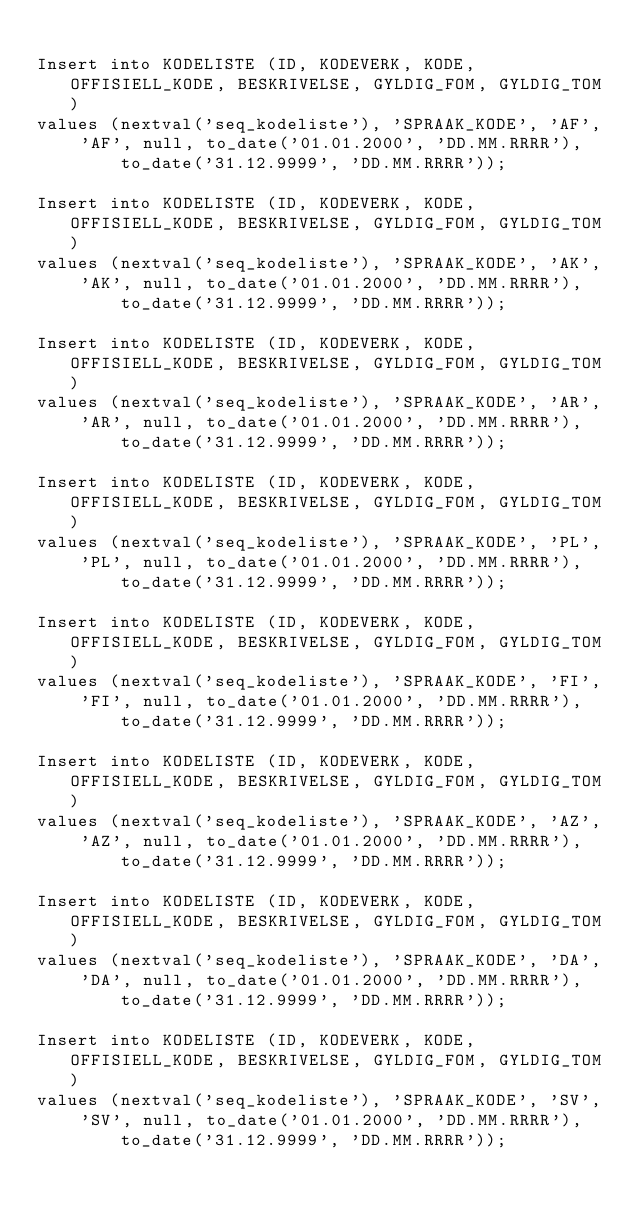<code> <loc_0><loc_0><loc_500><loc_500><_SQL_>
Insert into KODELISTE (ID, KODEVERK, KODE, OFFISIELL_KODE, BESKRIVELSE, GYLDIG_FOM, GYLDIG_TOM)
values (nextval('seq_kodeliste'), 'SPRAAK_KODE', 'AF', 'AF', null, to_date('01.01.2000', 'DD.MM.RRRR'),
        to_date('31.12.9999', 'DD.MM.RRRR'));

Insert into KODELISTE (ID, KODEVERK, KODE, OFFISIELL_KODE, BESKRIVELSE, GYLDIG_FOM, GYLDIG_TOM)
values (nextval('seq_kodeliste'), 'SPRAAK_KODE', 'AK', 'AK', null, to_date('01.01.2000', 'DD.MM.RRRR'),
        to_date('31.12.9999', 'DD.MM.RRRR'));

Insert into KODELISTE (ID, KODEVERK, KODE, OFFISIELL_KODE, BESKRIVELSE, GYLDIG_FOM, GYLDIG_TOM)
values (nextval('seq_kodeliste'), 'SPRAAK_KODE', 'AR', 'AR', null, to_date('01.01.2000', 'DD.MM.RRRR'),
        to_date('31.12.9999', 'DD.MM.RRRR'));

Insert into KODELISTE (ID, KODEVERK, KODE, OFFISIELL_KODE, BESKRIVELSE, GYLDIG_FOM, GYLDIG_TOM)
values (nextval('seq_kodeliste'), 'SPRAAK_KODE', 'PL', 'PL', null, to_date('01.01.2000', 'DD.MM.RRRR'),
        to_date('31.12.9999', 'DD.MM.RRRR'));

Insert into KODELISTE (ID, KODEVERK, KODE, OFFISIELL_KODE, BESKRIVELSE, GYLDIG_FOM, GYLDIG_TOM)
values (nextval('seq_kodeliste'), 'SPRAAK_KODE', 'FI', 'FI', null, to_date('01.01.2000', 'DD.MM.RRRR'),
        to_date('31.12.9999', 'DD.MM.RRRR'));

Insert into KODELISTE (ID, KODEVERK, KODE, OFFISIELL_KODE, BESKRIVELSE, GYLDIG_FOM, GYLDIG_TOM)
values (nextval('seq_kodeliste'), 'SPRAAK_KODE', 'AZ', 'AZ', null, to_date('01.01.2000', 'DD.MM.RRRR'),
        to_date('31.12.9999', 'DD.MM.RRRR'));

Insert into KODELISTE (ID, KODEVERK, KODE, OFFISIELL_KODE, BESKRIVELSE, GYLDIG_FOM, GYLDIG_TOM)
values (nextval('seq_kodeliste'), 'SPRAAK_KODE', 'DA', 'DA', null, to_date('01.01.2000', 'DD.MM.RRRR'),
        to_date('31.12.9999', 'DD.MM.RRRR'));

Insert into KODELISTE (ID, KODEVERK, KODE, OFFISIELL_KODE, BESKRIVELSE, GYLDIG_FOM, GYLDIG_TOM)
values (nextval('seq_kodeliste'), 'SPRAAK_KODE', 'SV', 'SV', null, to_date('01.01.2000', 'DD.MM.RRRR'),
        to_date('31.12.9999', 'DD.MM.RRRR'));</code> 